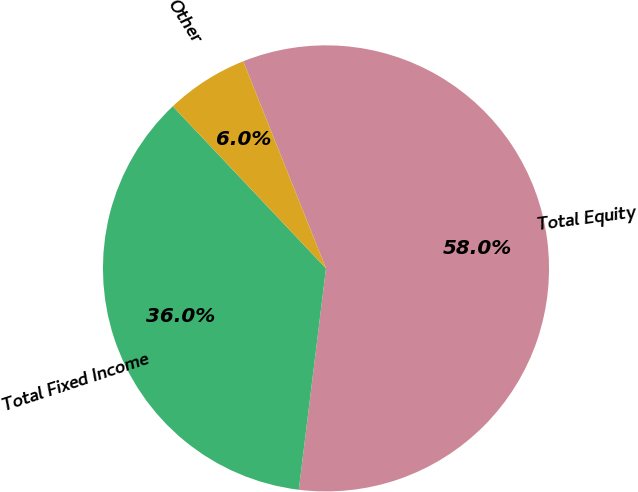Convert chart. <chart><loc_0><loc_0><loc_500><loc_500><pie_chart><fcel>Total Equity<fcel>Total Fixed Income<fcel>Other<nl><fcel>58.0%<fcel>36.0%<fcel>6.0%<nl></chart> 